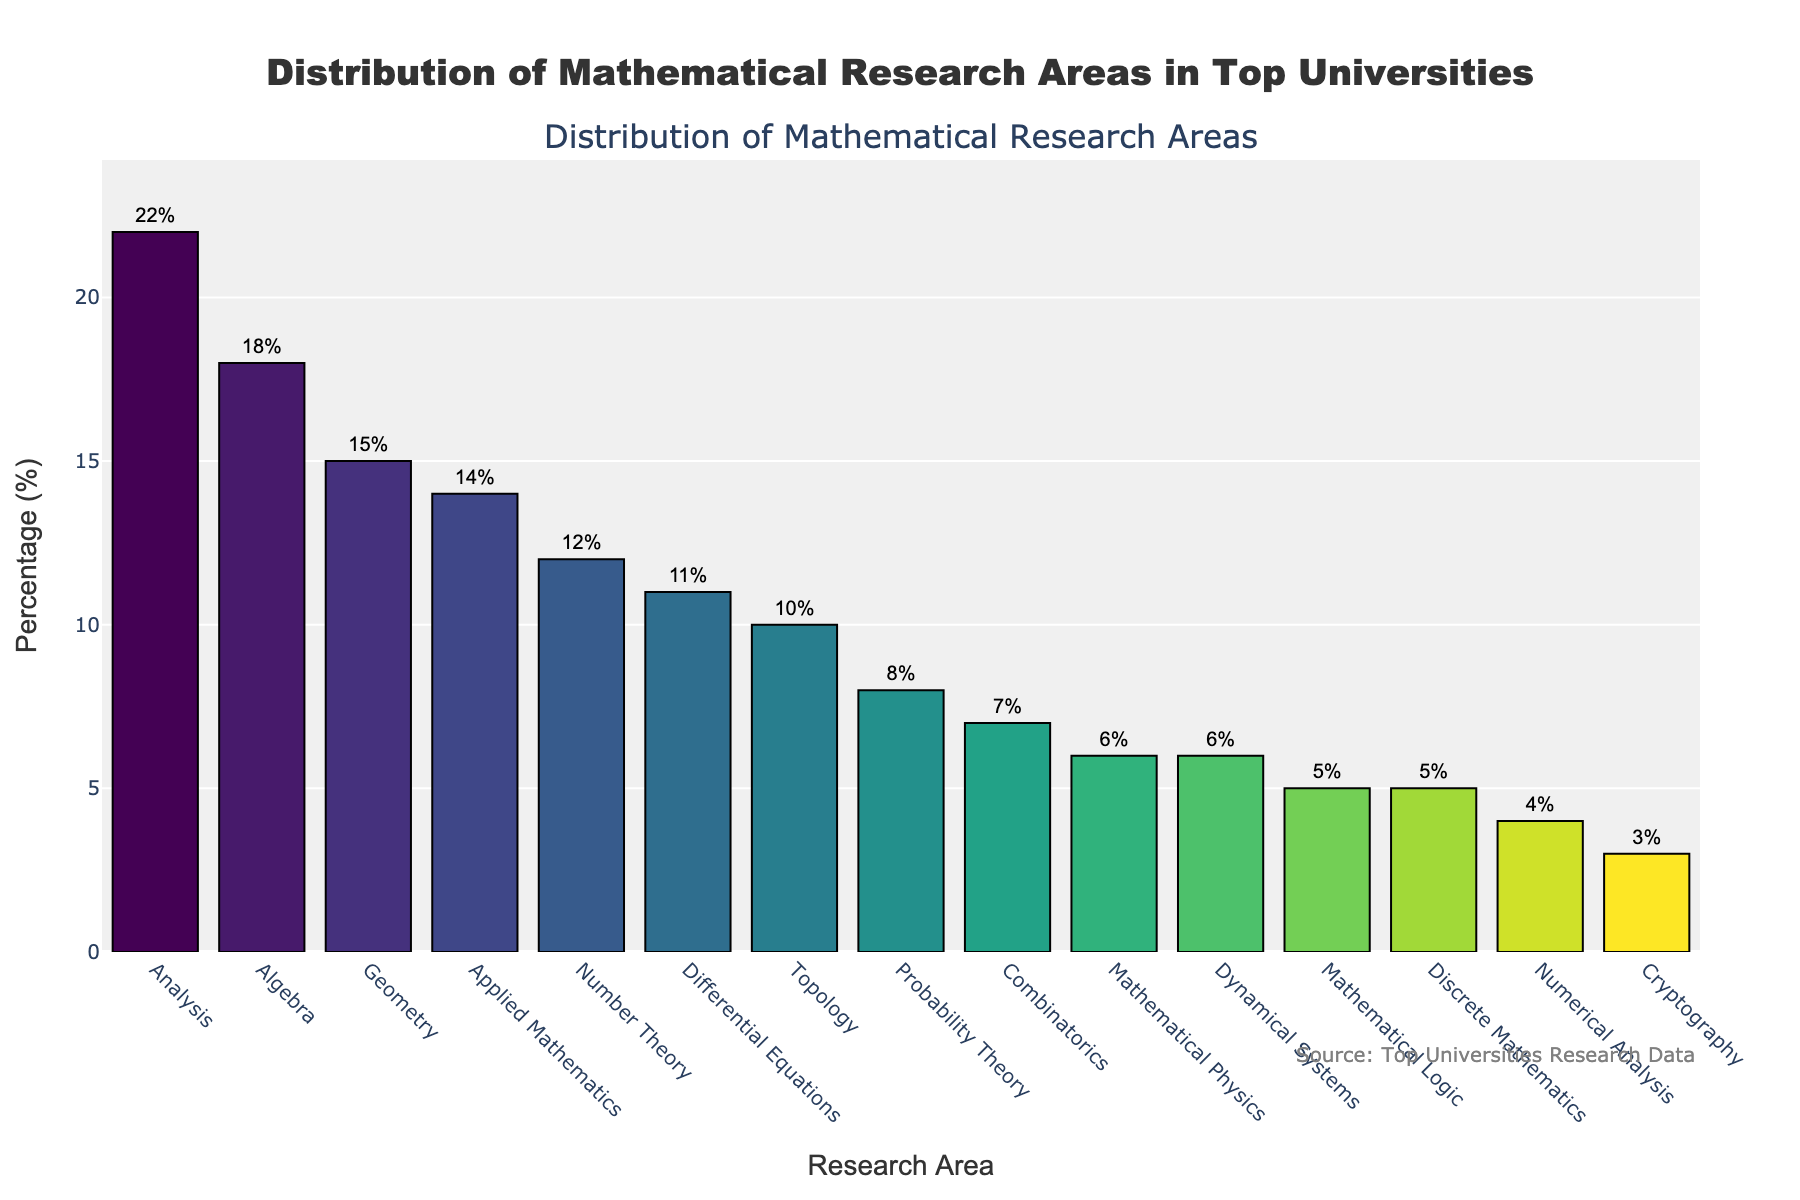What's the most represented area in top universities? By examining the bar chart, we can identify the tallest bar, which corresponds to the area with the highest percentage. The tallest bar is for "Analysis" with a percentage of 22%.
Answer: Analysis Which area has the lowest representation in the chart? To determine the area with the lowest representation, observe the shortest bar in the chart. The shortest bar represents "Cryptography," with a percentage of 3%.
Answer: Cryptography What's the combined percentage of research areas related to algebra and number theory? By adding the percentages for "Algebra" and "Number Theory": 18% for Algebra and 12% for Number Theory. So, 18 + 12 = 30%.
Answer: 30% How does the representation of Applied Mathematics compare to that of Geometry? Compare the heights of the bars for "Applied Mathematics" and "Geometry". "Applied Mathematics" has a percentage of 14%, and "Geometry" has a percentage of 15%. So, "Geometry" is slightly more represented.
Answer: Geometry is more represented Which areas have a percentage greater than 10%? Identify the bars that exceed the 10% mark: "Algebra" (18%), "Analysis" (22%), "Geometry" (15%), "Applied Mathematics" (14%), and "Differential Equations" (11%).
Answer: Algebra, Analysis, Geometry, Applied Mathematics, Differential Equations What's the sum of the percentages of research areas in Pure Mathematics (Algebra, Analysis, Geometry, Number Theory, Topology)? Add the percentages for "Algebra" (18%), "Analysis" (22%), "Geometry" (15%), "Number Theory" (12%), and "Topology" (10%). So, 18 + 22 + 15 + 12 + 10 = 77%.
Answer: 77% How much more represented is Analysis compared to Mathematical Logic? Subtract the percentage of "Mathematical Logic" from "Analysis". Analysis is 22% and Mathematical Logic is 5%. So, 22 - 5 = 17%.
Answer: 17% Which area has a color closest to the center of the Viridis color scale? The Viridis color scale ranges from darker purple to lighter yellow-green. The middle of the scale typically has a greenish color. "Probability Theory" and "Combinatorics" have bars with middle-range colors, so compare their shades. The bar for "Probability Theory" (8%) has a greenish color.
Answer: Probability Theory What’s the average percentage of all the areas combined? Sum all the percentages and divide by the number of areas: (18 + 22 + 15 + 12 + 10 + 14 + 5 + 8 + 7 + 11 + 6 + 5 + 3 + 4 + 6) / 15 = 11%.
Answer: 11% Which research areas have roughly similar percentages? Compare the heights and percentages of different bars. "Algebra" (18%) and "Applied Mathematics" (14%) have a small difference, and "Mathematical Physics" (6%) and "Discrete Mathematics" (5%) are quite similar. "Differential Equations" (11%) and "Number Theory" (12%) are also close.
Answer: Algebra & Applied Mathematics, Mathematical Physics & Discrete Mathematics, Differential Equations & Number Theory 